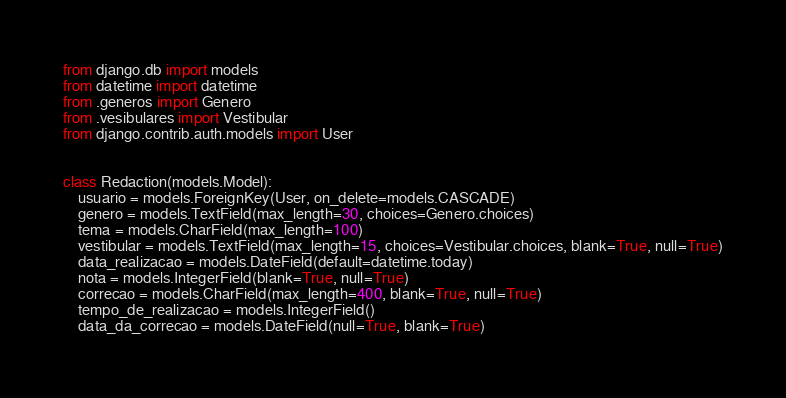<code> <loc_0><loc_0><loc_500><loc_500><_Python_>from django.db import models
from datetime import datetime
from .generos import Genero
from .vesibulares import Vestibular
from django.contrib.auth.models import User


class Redaction(models.Model):
    usuario = models.ForeignKey(User, on_delete=models.CASCADE)
    genero = models.TextField(max_length=30, choices=Genero.choices)
    tema = models.CharField(max_length=100)
    vestibular = models.TextField(max_length=15, choices=Vestibular.choices, blank=True, null=True)
    data_realizacao = models.DateField(default=datetime.today)
    nota = models.IntegerField(blank=True, null=True)
    correcao = models.CharField(max_length=400, blank=True, null=True)
    tempo_de_realizacao = models.IntegerField()
    data_da_correcao = models.DateField(null=True, blank=True)
</code> 